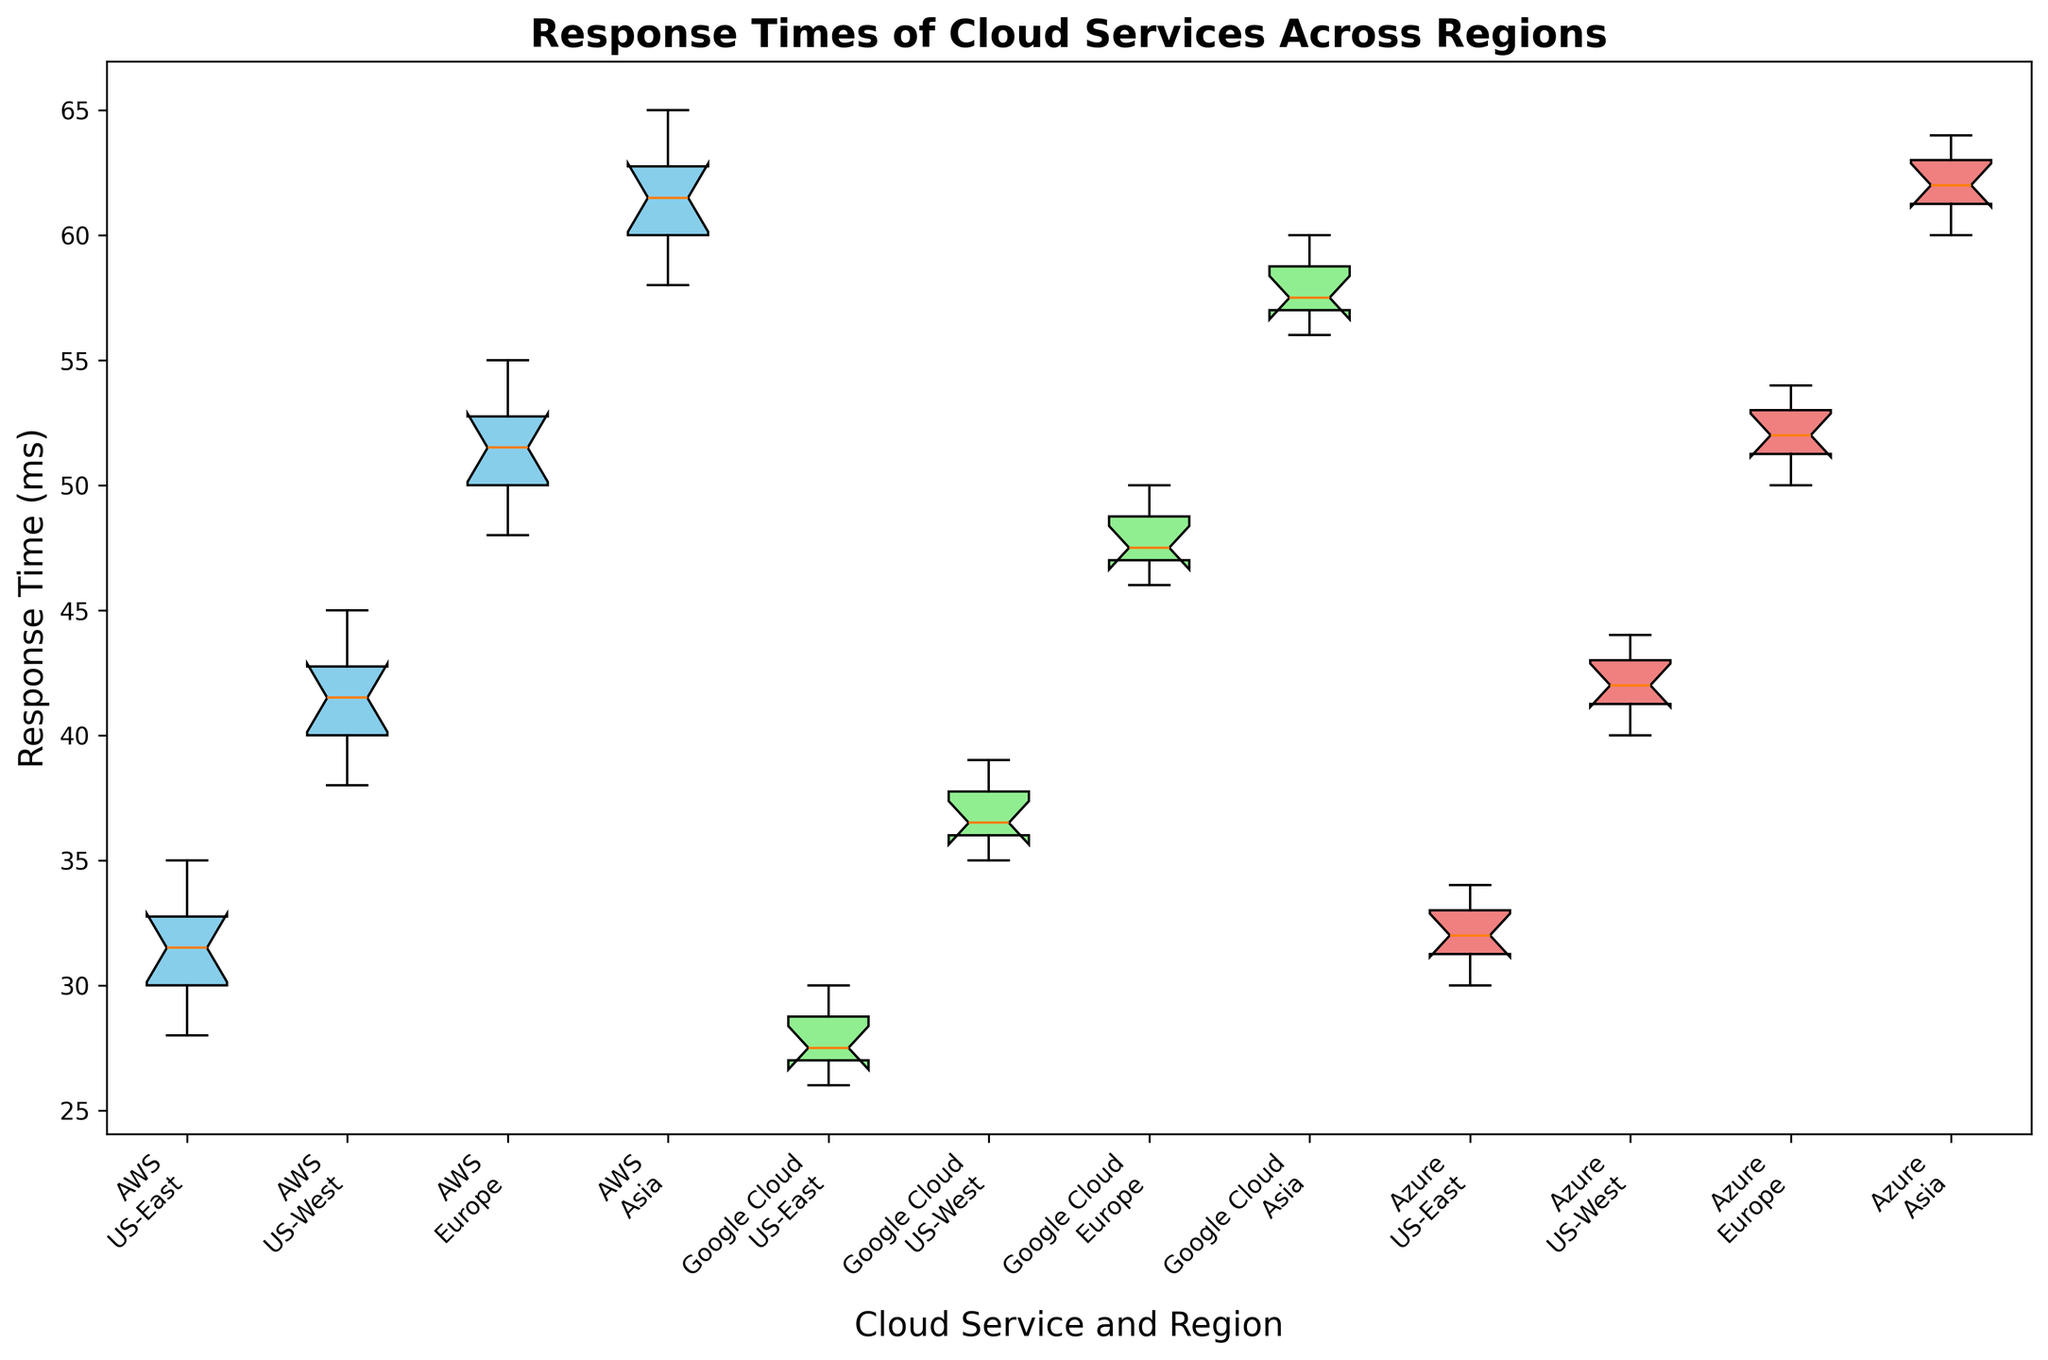Which cloud service has the lowest median response time in the US-East region? In the US-East region, look at the median line inside the box for each of the three cloud services. The lowest median line indicates the lowest median response time. Google Cloud has the lowest median response time in the US-East region.
Answer: Google Cloud Which cloud service shows the highest variability in response time in the Europe region? Look at the length of the boxes (interquartile ranges) and the length of the whiskers for each cloud service in the Europe region—the longer they are, the more variability they indicate. AWS shows the highest variability in the Europe region.
Answer: AWS Compare the median response times for AWS in the US-East and US-West regions. Which one is higher? Look at the median line inside the boxes for AWS in both the US-East and US-West regions. The line for the US-West region is higher.
Answer: US-West In the Asia region, which cloud service has the smallest interquartile range (IQR) for response times? The IQR is the length of the box in a box plot. Compare the lengths of the boxes for the three cloud services in the Asia region. Google Cloud has the smallest IQR.
Answer: Google Cloud What is the difference in median response times between Azure and AWS in the US-West region? Identify the median lines inside the boxes for Azure and AWS in the US-West region. Calculate the difference between them. Azure's median is at 42 ms, and AWS's median is at 42 ms, so the difference is 0 ms.
Answer: 0 ms Which cloud service in the Asia region has the median closest to 60 ms? Look at the median lines inside the boxes for the Asia region and find the one closest to the 60 ms mark. The median for both Google Cloud and Azure is close to 60 ms, but Azure is exactly at 62 ms, which is closer.
Answer: Azure Identify the cloud service and region with the highest median response time. Compare the median lines for all combinations of cloud services and regions. The combination with the highest median response time is AWS in the Asia region.
Answer: AWS, Asia Does Google Cloud or Azure have a higher median response time in the Europe region? Look at the median lines for Google Cloud and Azure in the Europe region. Azure has a higher median response time in the Europe region.
Answer: Azure Among all regions, which cloud service shows the lowest variability in response time? Identify the service with the shortest boxes and whiskers across all regions. Google Cloud in the US-East region shows the lowest variability.
Answer: Google Cloud in US-East How do the median response times for AWS compare across all regions? Look at the median lines for AWS in all regions: US-East, US-West, Europe, and Asia, and compare their heights. The medians increase from US-East (31 ms) to US-West (41 ms) to Europe (51 ms) to Asia (61 ms).
Answer: They increase from US-East to Asia 